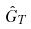<formula> <loc_0><loc_0><loc_500><loc_500>\hat { G } _ { T }</formula> 